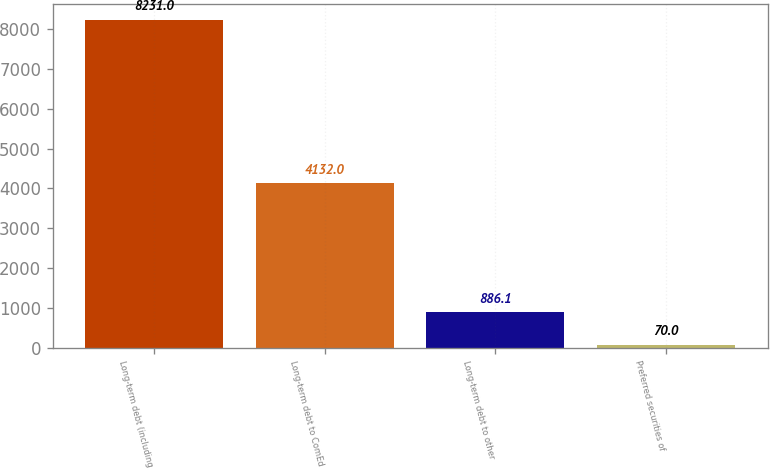Convert chart. <chart><loc_0><loc_0><loc_500><loc_500><bar_chart><fcel>Long-term debt (including<fcel>Long-term debt to ComEd<fcel>Long-term debt to other<fcel>Preferred securities of<nl><fcel>8231<fcel>4132<fcel>886.1<fcel>70<nl></chart> 